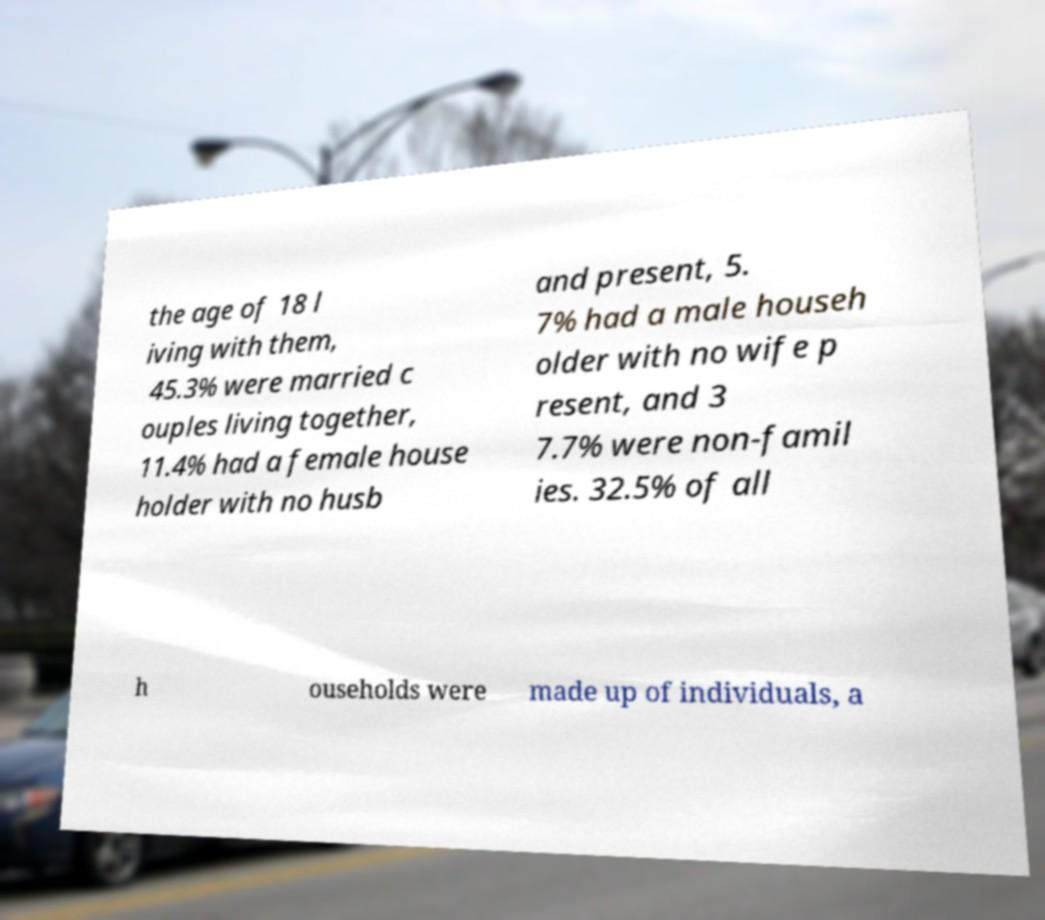Could you extract and type out the text from this image? the age of 18 l iving with them, 45.3% were married c ouples living together, 11.4% had a female house holder with no husb and present, 5. 7% had a male househ older with no wife p resent, and 3 7.7% were non-famil ies. 32.5% of all h ouseholds were made up of individuals, a 